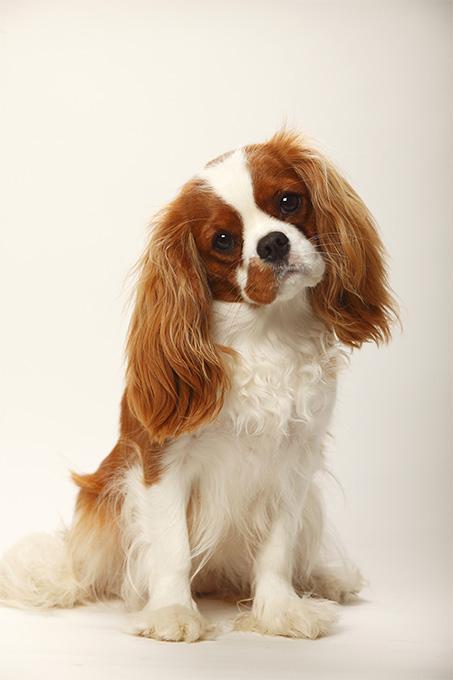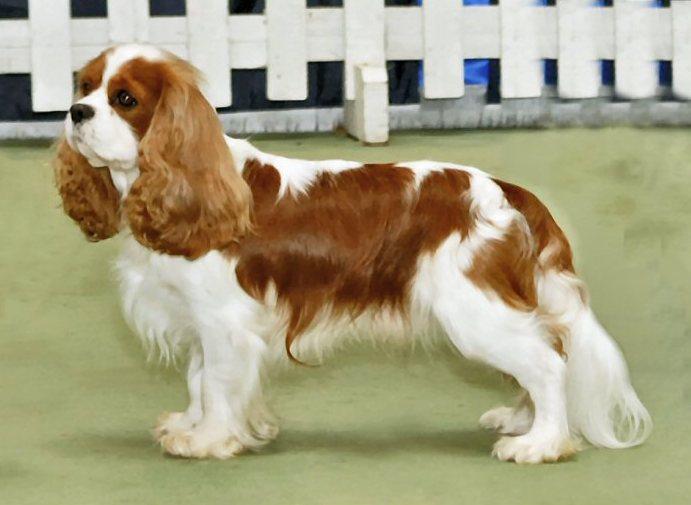The first image is the image on the left, the second image is the image on the right. Assess this claim about the two images: "there are three animals.". Correct or not? Answer yes or no. No. The first image is the image on the left, the second image is the image on the right. Examine the images to the left and right. Is the description "There are no more than two animals" accurate? Answer yes or no. Yes. 